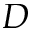<formula> <loc_0><loc_0><loc_500><loc_500>D</formula> 